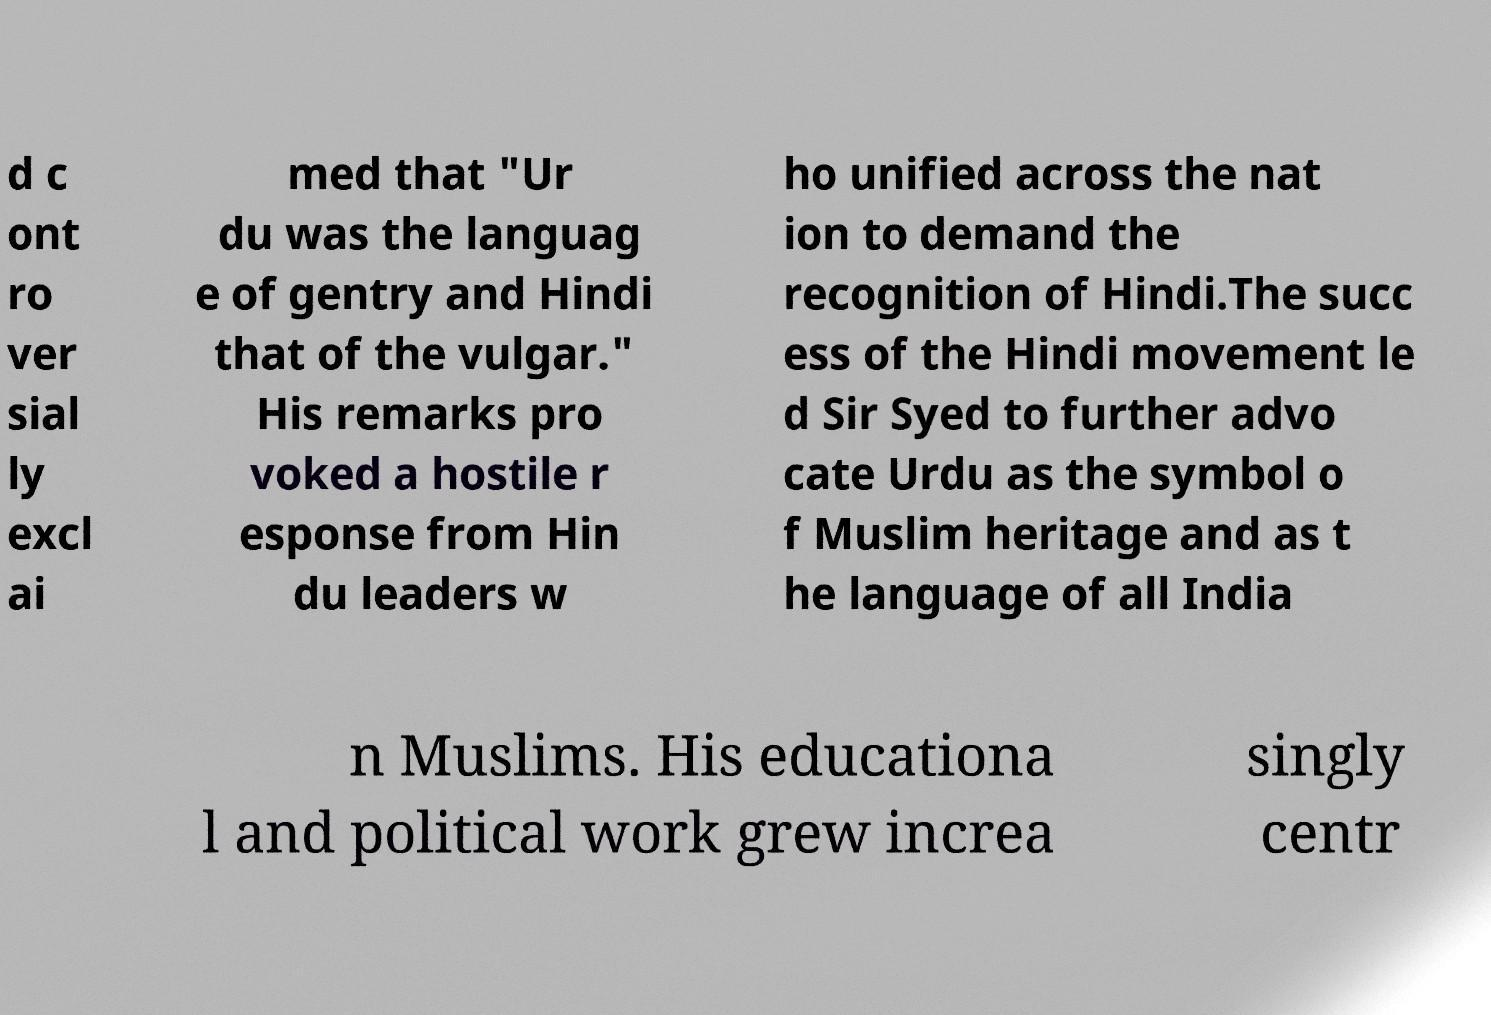Could you assist in decoding the text presented in this image and type it out clearly? d c ont ro ver sial ly excl ai med that "Ur du was the languag e of gentry and Hindi that of the vulgar." His remarks pro voked a hostile r esponse from Hin du leaders w ho unified across the nat ion to demand the recognition of Hindi.The succ ess of the Hindi movement le d Sir Syed to further advo cate Urdu as the symbol o f Muslim heritage and as t he language of all India n Muslims. His educationa l and political work grew increa singly centr 